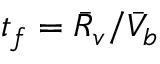<formula> <loc_0><loc_0><loc_500><loc_500>t _ { f } = \bar { R } _ { v } / \bar { V } _ { b }</formula> 